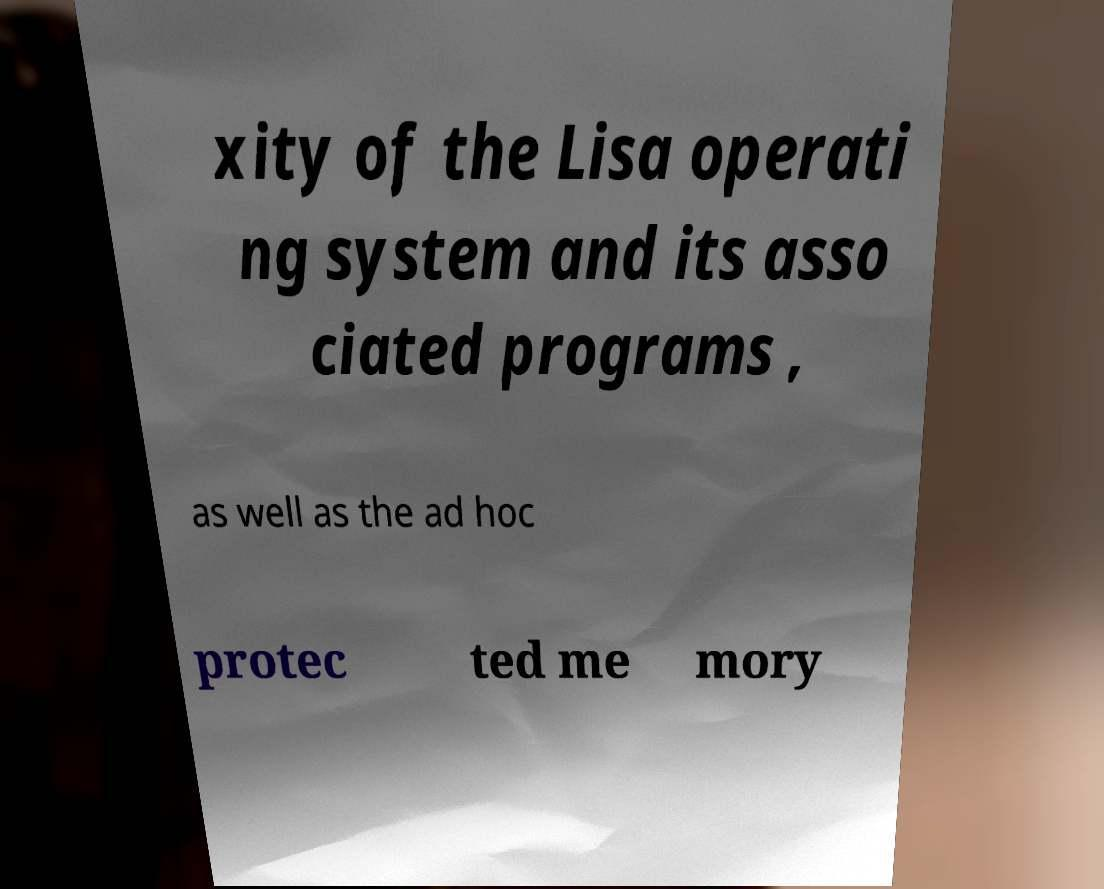Can you accurately transcribe the text from the provided image for me? xity of the Lisa operati ng system and its asso ciated programs , as well as the ad hoc protec ted me mory 